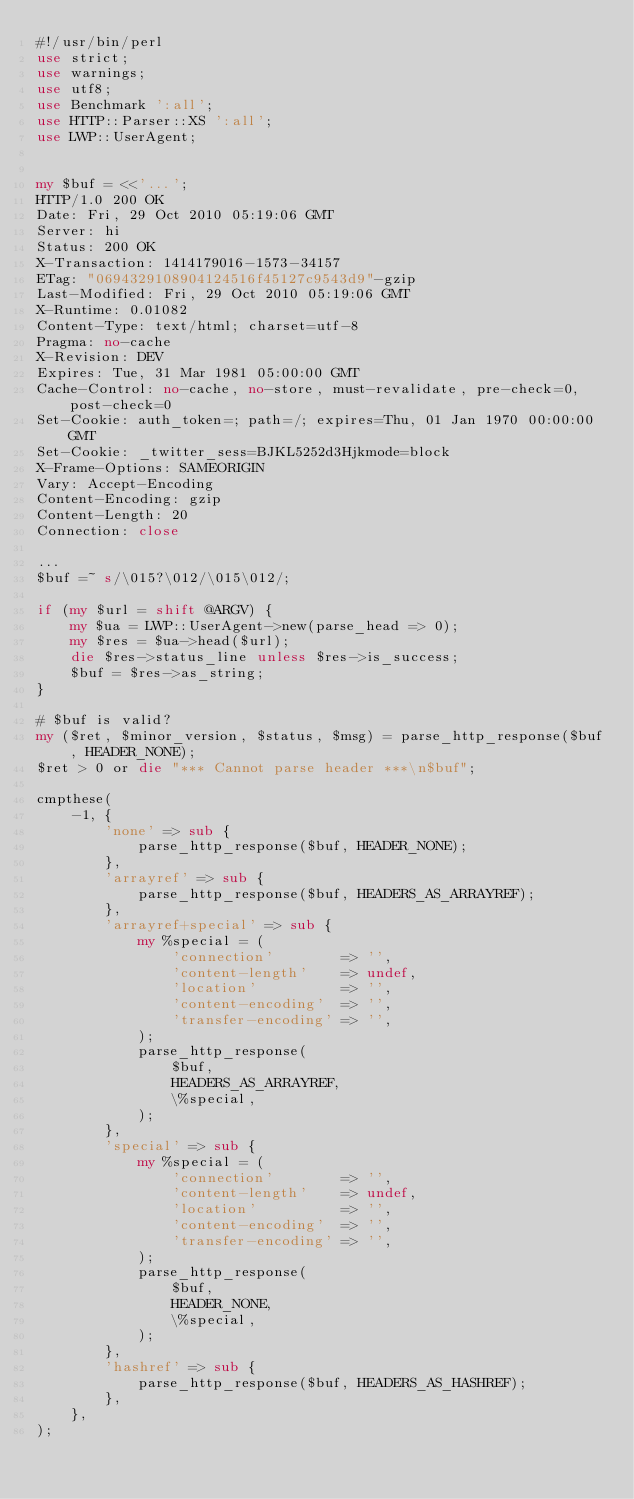<code> <loc_0><loc_0><loc_500><loc_500><_Perl_>#!/usr/bin/perl
use strict;
use warnings;
use utf8;
use Benchmark ':all';
use HTTP::Parser::XS ':all';
use LWP::UserAgent;


my $buf = <<'...';
HTTP/1.0 200 OK
Date: Fri, 29 Oct 2010 05:19:06 GMT
Server: hi
Status: 200 OK
X-Transaction: 1414179016-1573-34157
ETag: "0694329108904124516f45127c9543d9"-gzip
Last-Modified: Fri, 29 Oct 2010 05:19:06 GMT
X-Runtime: 0.01082
Content-Type: text/html; charset=utf-8
Pragma: no-cache
X-Revision: DEV
Expires: Tue, 31 Mar 1981 05:00:00 GMT
Cache-Control: no-cache, no-store, must-revalidate, pre-check=0, post-check=0
Set-Cookie: auth_token=; path=/; expires=Thu, 01 Jan 1970 00:00:00 GMT
Set-Cookie: _twitter_sess=BJKL5252d3Hjkmode=block
X-Frame-Options: SAMEORIGIN
Vary: Accept-Encoding
Content-Encoding: gzip
Content-Length: 20
Connection: close

...
$buf =~ s/\015?\012/\015\012/;

if (my $url = shift @ARGV) {
    my $ua = LWP::UserAgent->new(parse_head => 0);
    my $res = $ua->head($url);
    die $res->status_line unless $res->is_success;
    $buf = $res->as_string;
}

# $buf is valid?
my ($ret, $minor_version, $status, $msg) = parse_http_response($buf, HEADER_NONE);
$ret > 0 or die "*** Cannot parse header ***\n$buf";

cmpthese(
    -1, {
        'none' => sub {
            parse_http_response($buf, HEADER_NONE);
        },
        'arrayref' => sub {
            parse_http_response($buf, HEADERS_AS_ARRAYREF);
        },
        'arrayref+special' => sub {
            my %special = (
                'connection'        => '',
                'content-length'    => undef,
                'location'          => '',
                'content-encoding'  => '',
                'transfer-encoding' => '',
            );
            parse_http_response(
                $buf,
                HEADERS_AS_ARRAYREF,
                \%special,
            );
        },
        'special' => sub {
            my %special = (
                'connection'        => '',
                'content-length'    => undef,
                'location'          => '',
                'content-encoding'  => '',
                'transfer-encoding' => '',
            );
            parse_http_response(
                $buf,
                HEADER_NONE,
                \%special,
            );
        },
        'hashref' => sub {
            parse_http_response($buf, HEADERS_AS_HASHREF);
        },
    },
);

</code> 